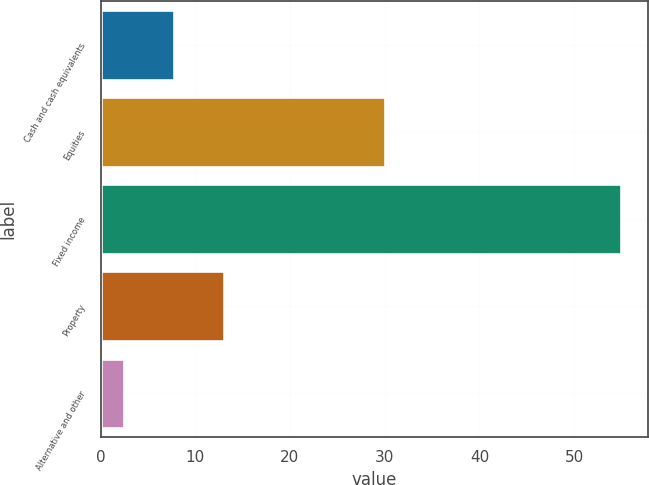Convert chart. <chart><loc_0><loc_0><loc_500><loc_500><bar_chart><fcel>Cash and cash equivalents<fcel>Equities<fcel>Fixed income<fcel>Property<fcel>Alternative and other<nl><fcel>7.76<fcel>30<fcel>55<fcel>13.01<fcel>2.51<nl></chart> 